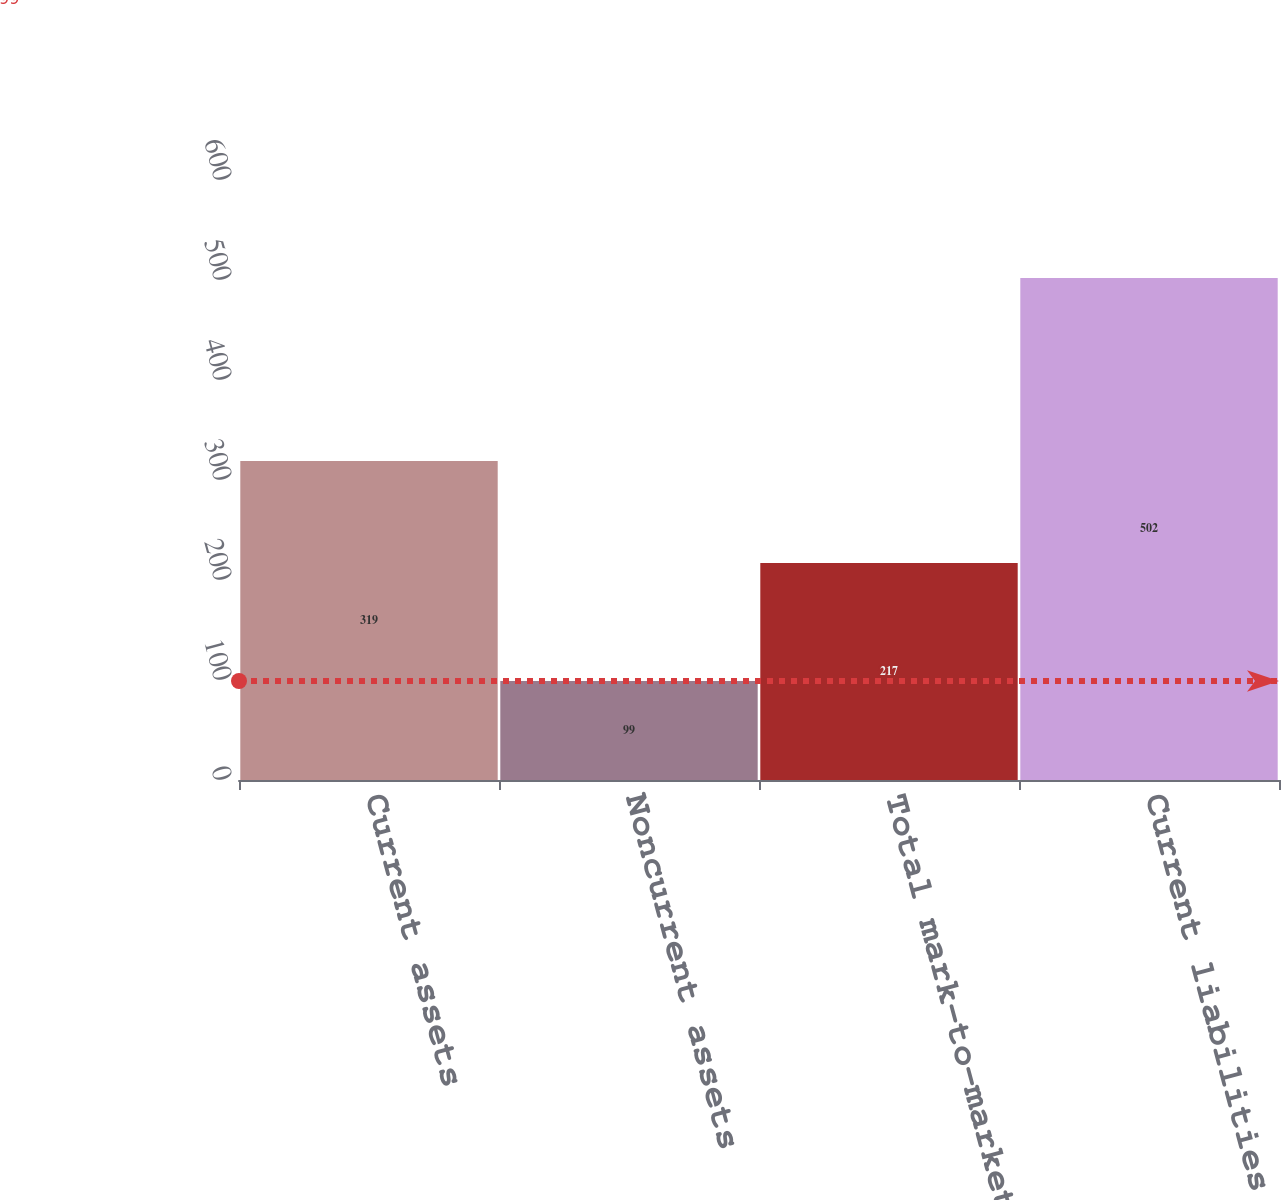<chart> <loc_0><loc_0><loc_500><loc_500><bar_chart><fcel>Current assets<fcel>Noncurrent assets<fcel>Total mark-to-market energy<fcel>Current liabilities<nl><fcel>319<fcel>99<fcel>217<fcel>502<nl></chart> 